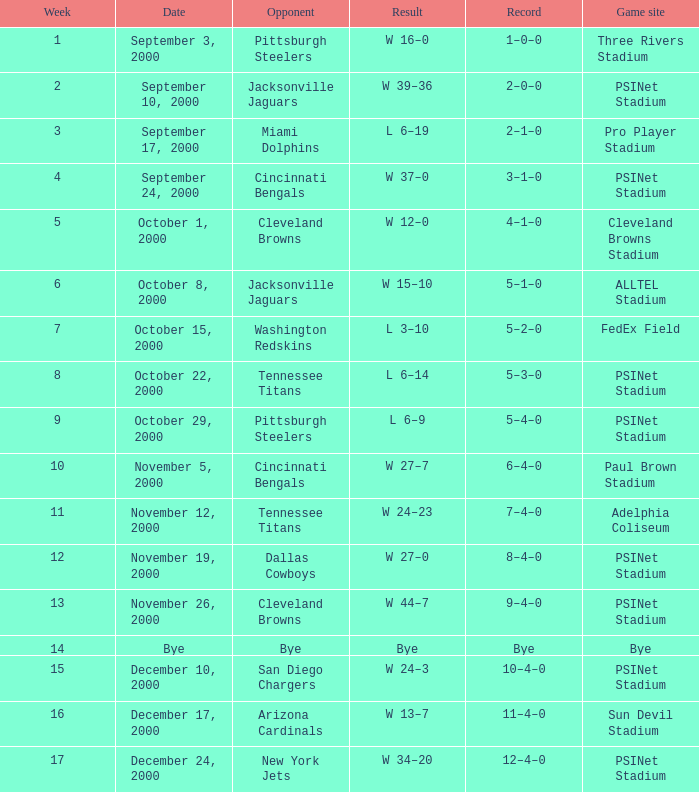What's the upshot at psinet stadium when the cincinnati bengals are the competitor? W 37–0. 